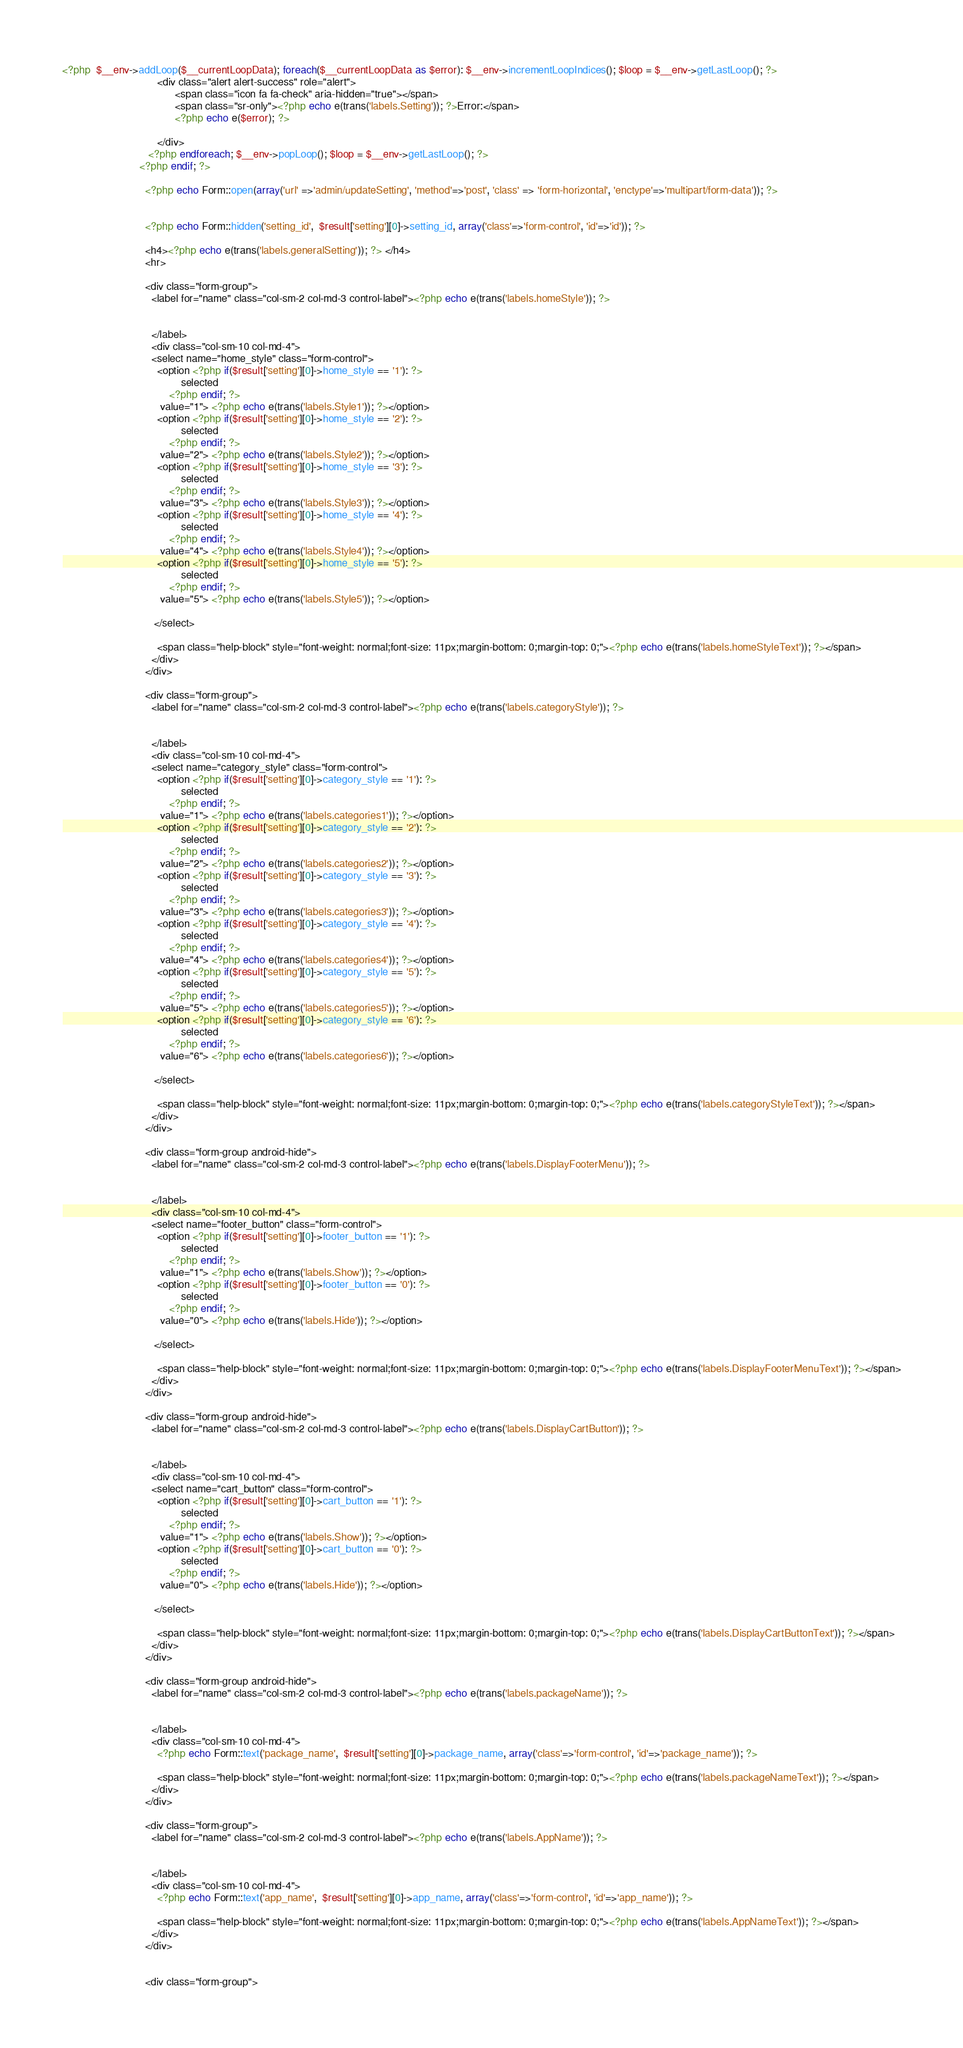<code> <loc_0><loc_0><loc_500><loc_500><_PHP_><?php  $__env->addLoop($__currentLoopData); foreach($__currentLoopData as $error): $__env->incrementLoopIndices(); $loop = $__env->getLastLoop(); ?>
                                <div class="alert alert-success" role="alert">
                                      <span class="icon fa fa-check" aria-hidden="true"></span>
                                      <span class="sr-only"><?php echo e(trans('labels.Setting')); ?>Error:</span>
                                      <?php echo e($error); ?>

                                </div>
                             <?php endforeach; $__env->popLoop(); $loop = $__env->getLastLoop(); ?>
                          <?php endif; ?>
                        
                            <?php echo Form::open(array('url' =>'admin/updateSetting', 'method'=>'post', 'class' => 'form-horizontal', 'enctype'=>'multipart/form-data')); ?>

                            	
                            <?php echo Form::hidden('setting_id',  $result['setting'][0]->setting_id, array('class'=>'form-control', 'id'=>'id')); ?>

                            <h4><?php echo e(trans('labels.generalSetting')); ?> </h4>
                            <hr>
                            
                            <div class="form-group">
                              <label for="name" class="col-sm-2 col-md-3 control-label"><?php echo e(trans('labels.homeStyle')); ?>

                              
                              </label>
                              <div class="col-sm-10 col-md-4">
                              <select name="home_style" class="form-control">
                              	<option <?php if($result['setting'][0]->home_style == '1'): ?>
                                        selected
                                    <?php endif; ?>
                                 value="1"> <?php echo e(trans('labels.Style1')); ?></option>
                                <option <?php if($result['setting'][0]->home_style == '2'): ?>
                                        selected
                                    <?php endif; ?>
                                 value="2"> <?php echo e(trans('labels.Style2')); ?></option>
                              	<option <?php if($result['setting'][0]->home_style == '3'): ?>
                                        selected
                                    <?php endif; ?>
                                 value="3"> <?php echo e(trans('labels.Style3')); ?></option>
                                <option <?php if($result['setting'][0]->home_style == '4'): ?>
                                        selected
                                    <?php endif; ?>
                                 value="4"> <?php echo e(trans('labels.Style4')); ?></option>
                              	<option <?php if($result['setting'][0]->home_style == '5'): ?>
                                        selected
                                    <?php endif; ?>
                                 value="5"> <?php echo e(trans('labels.Style5')); ?></option>                                   
                                         
                               </select>
                                
                                <span class="help-block" style="font-weight: normal;font-size: 11px;margin-bottom: 0;margin-top: 0;"><?php echo e(trans('labels.homeStyleText')); ?></span>
                              </div>
                            </div>
                            
                            <div class="form-group">
                              <label for="name" class="col-sm-2 col-md-3 control-label"><?php echo e(trans('labels.categoryStyle')); ?>

                              
                              </label>
                              <div class="col-sm-10 col-md-4">
                              <select name="category_style" class="form-control">
                              	<option <?php if($result['setting'][0]->category_style == '1'): ?>
                                        selected
                                    <?php endif; ?>
                                 value="1"> <?php echo e(trans('labels.categories1')); ?></option>
                                <option <?php if($result['setting'][0]->category_style == '2'): ?>
                                        selected
                                    <?php endif; ?>
                                 value="2"> <?php echo e(trans('labels.categories2')); ?></option>
                              	<option <?php if($result['setting'][0]->category_style == '3'): ?>
                                        selected
                                    <?php endif; ?>
                                 value="3"> <?php echo e(trans('labels.categories3')); ?></option>
                                <option <?php if($result['setting'][0]->category_style == '4'): ?>
                                        selected
                                    <?php endif; ?>
                                 value="4"> <?php echo e(trans('labels.categories4')); ?></option>
                              	<option <?php if($result['setting'][0]->category_style == '5'): ?>
                                        selected
                                    <?php endif; ?>
                                 value="5"> <?php echo e(trans('labels.categories5')); ?></option>  
                              	<option <?php if($result['setting'][0]->category_style == '6'): ?>
                                        selected
                                    <?php endif; ?>
                                 value="6"> <?php echo e(trans('labels.categories6')); ?></option>                                   
                                         
                               </select>
                                
                                <span class="help-block" style="font-weight: normal;font-size: 11px;margin-bottom: 0;margin-top: 0;"><?php echo e(trans('labels.categoryStyleText')); ?></span>
                              </div>
                            </div>
                            
                            <div class="form-group android-hide">
                              <label for="name" class="col-sm-2 col-md-3 control-label"><?php echo e(trans('labels.DisplayFooterMenu')); ?>

                              
                              </label>
                              <div class="col-sm-10 col-md-4">
                              <select name="footer_button" class="form-control">
                              	<option <?php if($result['setting'][0]->footer_button == '1'): ?>
                                        selected
                                    <?php endif; ?>
                                 value="1"> <?php echo e(trans('labels.Show')); ?></option>
                              	<option <?php if($result['setting'][0]->footer_button == '0'): ?>
                                        selected
                                    <?php endif; ?>
                                 value="0"> <?php echo e(trans('labels.Hide')); ?></option>
                                         
                               </select>
                                
                                <span class="help-block" style="font-weight: normal;font-size: 11px;margin-bottom: 0;margin-top: 0;"><?php echo e(trans('labels.DisplayFooterMenuText')); ?></span>
                              </div>
                            </div>
                            
                            <div class="form-group android-hide">
                              <label for="name" class="col-sm-2 col-md-3 control-label"><?php echo e(trans('labels.DisplayCartButton')); ?>

                              
                              </label>
                              <div class="col-sm-10 col-md-4">
                              <select name="cart_button" class="form-control">
                              	<option <?php if($result['setting'][0]->cart_button == '1'): ?>
                                        selected
                                    <?php endif; ?>
                                 value="1"> <?php echo e(trans('labels.Show')); ?></option>
                              	<option <?php if($result['setting'][0]->cart_button == '0'): ?>
                                        selected
                                    <?php endif; ?>
                                 value="0"> <?php echo e(trans('labels.Hide')); ?></option>
                                         
                               </select>
                                
                                <span class="help-block" style="font-weight: normal;font-size: 11px;margin-bottom: 0;margin-top: 0;"><?php echo e(trans('labels.DisplayCartButtonText')); ?></span>
                              </div>
                            </div>
                            
                            <div class="form-group android-hide">
                              <label for="name" class="col-sm-2 col-md-3 control-label"><?php echo e(trans('labels.packageName')); ?>

                              
                              </label>
                              <div class="col-sm-10 col-md-4">
                                <?php echo Form::text('package_name',  $result['setting'][0]->package_name, array('class'=>'form-control', 'id'=>'package_name')); ?>

                                <span class="help-block" style="font-weight: normal;font-size: 11px;margin-bottom: 0;margin-top: 0;"><?php echo e(trans('labels.packageNameText')); ?></span>
                              </div>
                            </div>
                            
                            <div class="form-group">
                              <label for="name" class="col-sm-2 col-md-3 control-label"><?php echo e(trans('labels.AppName')); ?>

                              
                              </label>
                              <div class="col-sm-10 col-md-4">
                                <?php echo Form::text('app_name',  $result['setting'][0]->app_name, array('class'=>'form-control', 'id'=>'app_name')); ?>

                                <span class="help-block" style="font-weight: normal;font-size: 11px;margin-bottom: 0;margin-top: 0;"><?php echo e(trans('labels.AppNameText')); ?></span>
                              </div>
                            </div>
                            
                            
                            <div class="form-group"></code> 